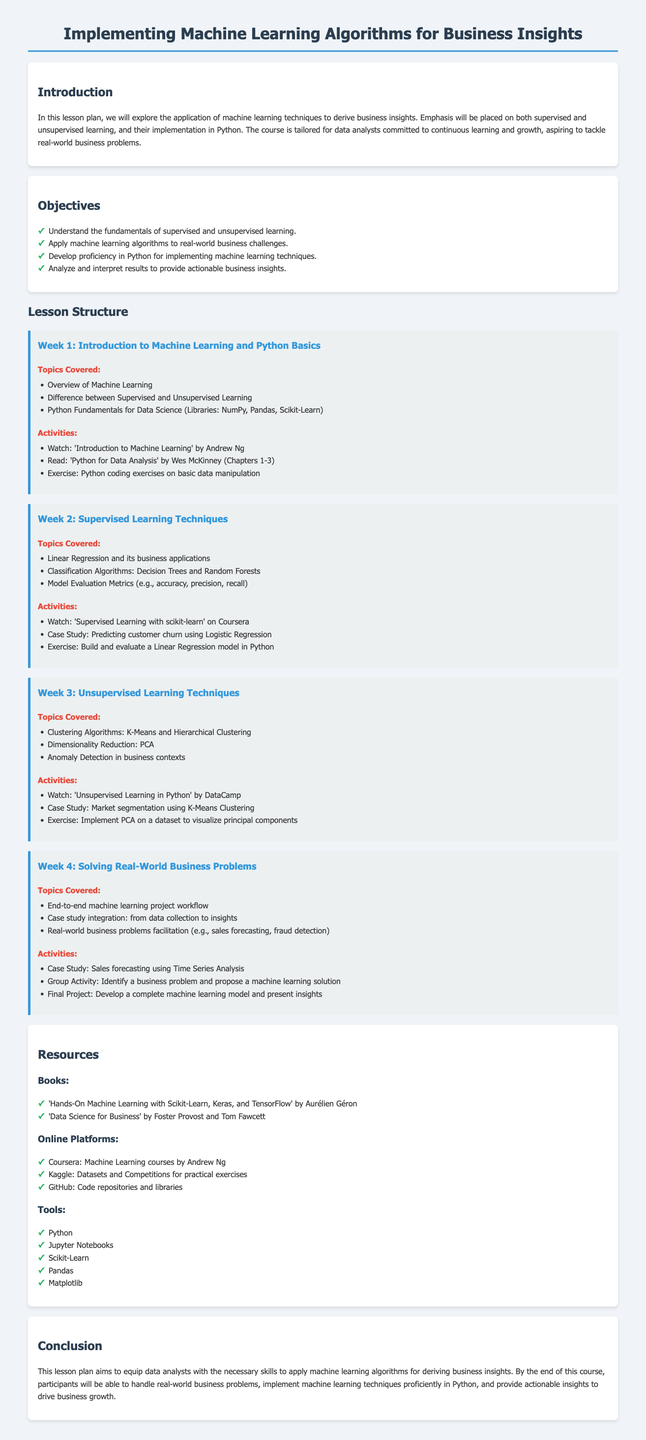What is the title of the lesson plan? The title describes the focus of the document on machine learning and its applications in business insights.
Answer: Implementing Machine Learning Algorithms for Business Insights How many weeks is the lesson plan structured into? The document outlines a four-week lesson structure, indicating the duration of the course.
Answer: 4 Name one supervised learning technique covered in the lesson plan. The topics list includes specific supervised learning techniques utilized in business contexts.
Answer: Linear Regression What is one tool mentioned for implementing machine learning techniques? The resources section lists tools necessary for machine learning, highlighting software commonly used in the field.
Answer: Python What type of learning is emphasized in Week 3? The structure for Week 3 specifies the focus of the topics covered during that week.
Answer: Unsupervised Learning Techniques What is the final project of the course? The activities in Week 4 elucidate the culminating project that students must complete at the end of the course.
Answer: Develop a complete machine learning model and present insights Which book is recommended for understanding data science in business? The resources section includes titles that provide foundational knowledge relevant to data science in a business context.
Answer: Data Science for Business What is one online platform listed for learning resources? The resources section specifies online platforms that offer courses and materials related to machine learning.
Answer: Coursera 